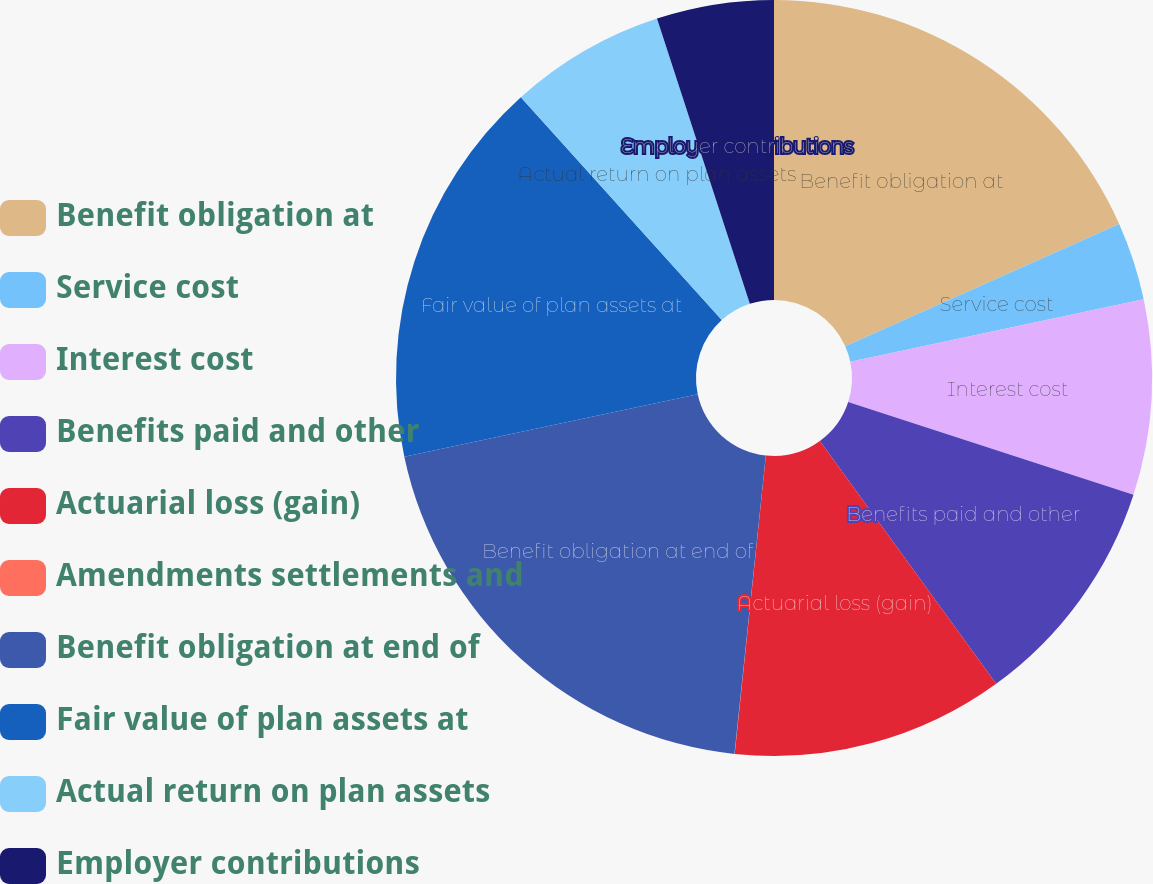Convert chart. <chart><loc_0><loc_0><loc_500><loc_500><pie_chart><fcel>Benefit obligation at<fcel>Service cost<fcel>Interest cost<fcel>Benefits paid and other<fcel>Actuarial loss (gain)<fcel>Amendments settlements and<fcel>Benefit obligation at end of<fcel>Fair value of plan assets at<fcel>Actual return on plan assets<fcel>Employer contributions<nl><fcel>18.32%<fcel>3.34%<fcel>8.34%<fcel>10.0%<fcel>11.66%<fcel>0.01%<fcel>19.99%<fcel>16.66%<fcel>6.67%<fcel>5.01%<nl></chart> 